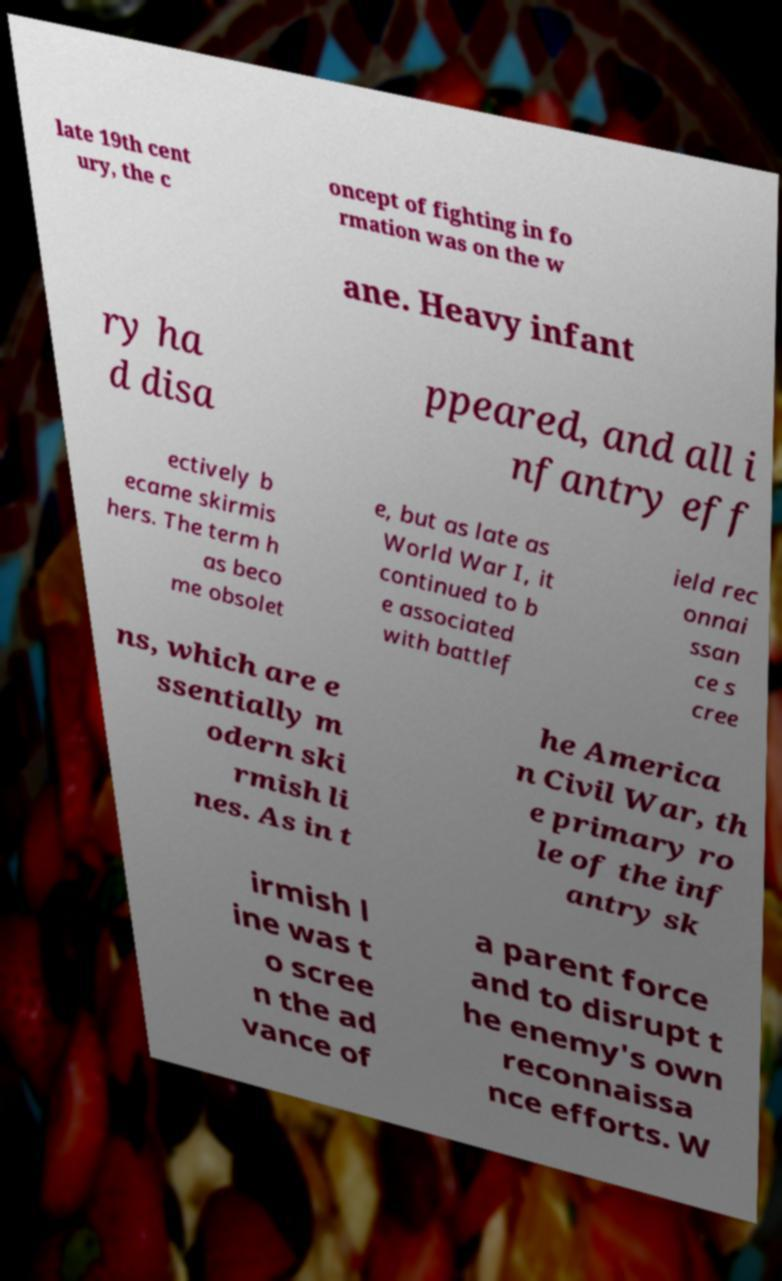Could you assist in decoding the text presented in this image and type it out clearly? late 19th cent ury, the c oncept of fighting in fo rmation was on the w ane. Heavy infant ry ha d disa ppeared, and all i nfantry eff ectively b ecame skirmis hers. The term h as beco me obsolet e, but as late as World War I, it continued to b e associated with battlef ield rec onnai ssan ce s cree ns, which are e ssentially m odern ski rmish li nes. As in t he America n Civil War, th e primary ro le of the inf antry sk irmish l ine was t o scree n the ad vance of a parent force and to disrupt t he enemy's own reconnaissa nce efforts. W 